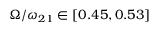<formula> <loc_0><loc_0><loc_500><loc_500>\Omega / \omega _ { 2 1 } \in [ 0 . 4 5 , 0 . 5 3 ]</formula> 